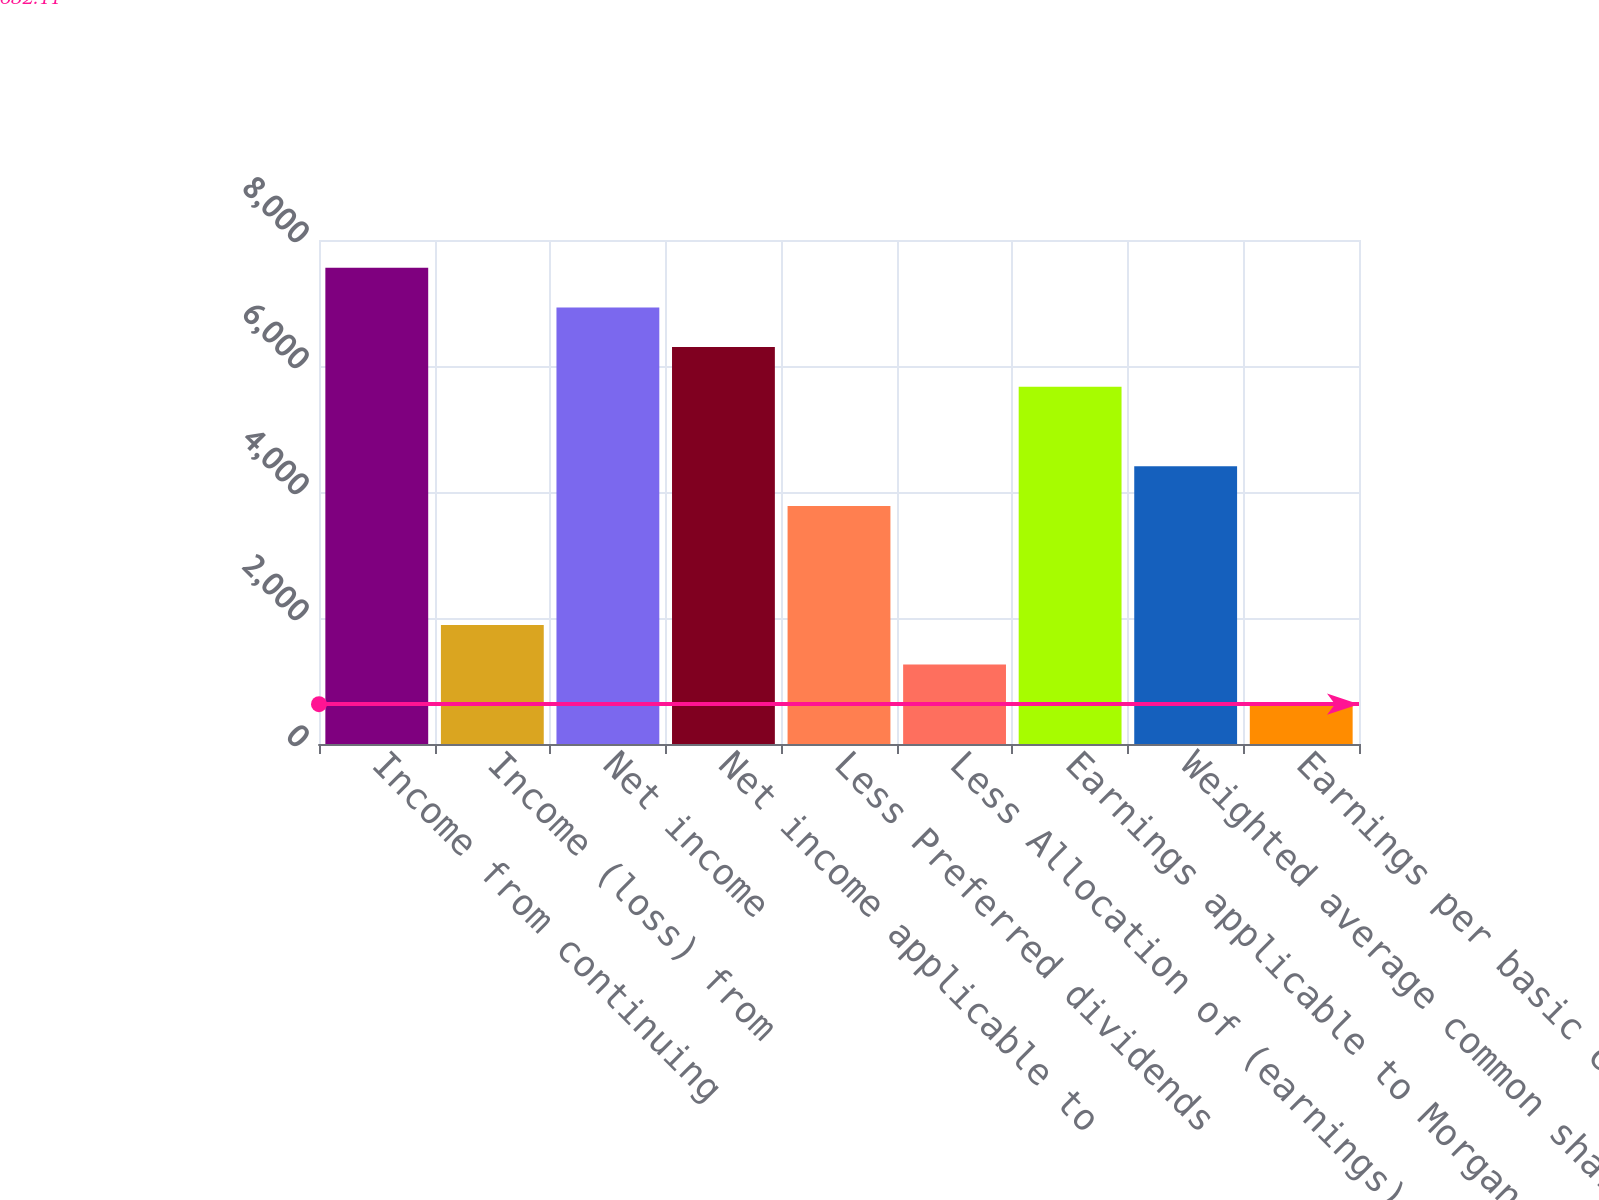Convert chart to OTSL. <chart><loc_0><loc_0><loc_500><loc_500><bar_chart><fcel>Income from continuing<fcel>Income (loss) from<fcel>Net income<fcel>Net income applicable to<fcel>Less Preferred dividends<fcel>Less Allocation of (earnings)<fcel>Earnings applicable to Morgan<fcel>Weighted average common shares<fcel>Earnings per basic common<nl><fcel>7558.63<fcel>1890.53<fcel>6929.42<fcel>6300.21<fcel>3778.16<fcel>1261.32<fcel>5671<fcel>4407.37<fcel>632.11<nl></chart> 